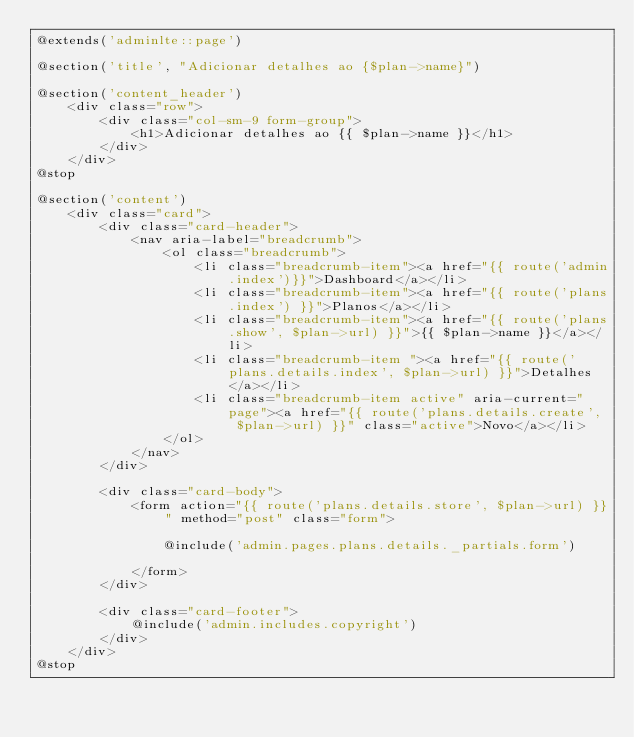<code> <loc_0><loc_0><loc_500><loc_500><_PHP_>@extends('adminlte::page')

@section('title', "Adicionar detalhes ao {$plan->name}")

@section('content_header')
    <div class="row">
        <div class="col-sm-9 form-group">
            <h1>Adicionar detalhes ao {{ $plan->name }}</h1>
        </div>
    </div>
@stop

@section('content')
    <div class="card">
        <div class="card-header">
            <nav aria-label="breadcrumb">
                <ol class="breadcrumb">
                    <li class="breadcrumb-item"><a href="{{ route('admin.index')}}">Dashboard</a></li>
                    <li class="breadcrumb-item"><a href="{{ route('plans.index') }}">Planos</a></li>
                    <li class="breadcrumb-item"><a href="{{ route('plans.show', $plan->url) }}">{{ $plan->name }}</a></li>
                    <li class="breadcrumb-item "><a href="{{ route('plans.details.index', $plan->url) }}">Detalhes</a></li>
                    <li class="breadcrumb-item active" aria-current="page"><a href="{{ route('plans.details.create', $plan->url) }}" class="active">Novo</a></li>
                </ol>
            </nav>
        </div>

        <div class="card-body">
            <form action="{{ route('plans.details.store', $plan->url) }}" method="post" class="form">

                @include('admin.pages.plans.details._partials.form')

            </form>
        </div>

        <div class="card-footer">
            @include('admin.includes.copyright')
        </div>
    </div>
@stop
</code> 